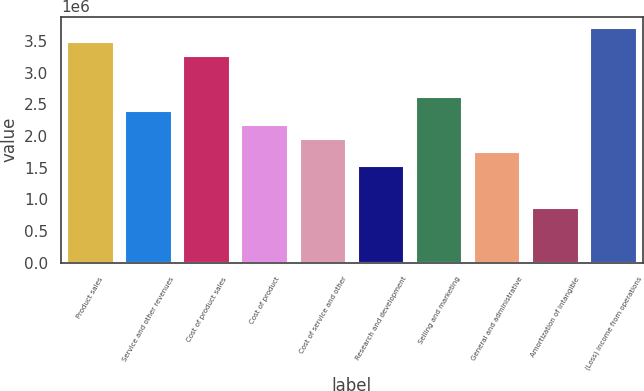<chart> <loc_0><loc_0><loc_500><loc_500><bar_chart><fcel>Product sales<fcel>Service and other revenues<fcel>Cost of product sales<fcel>Cost of product<fcel>Cost of service and other<fcel>Research and development<fcel>Selling and marketing<fcel>General and administrative<fcel>Amortization of intangible<fcel>(Loss) income from operations<nl><fcel>3.48197e+06<fcel>2.39386e+06<fcel>3.26435e+06<fcel>2.17624e+06<fcel>1.95861e+06<fcel>1.52337e+06<fcel>2.61148e+06<fcel>1.74099e+06<fcel>870500<fcel>3.6996e+06<nl></chart> 